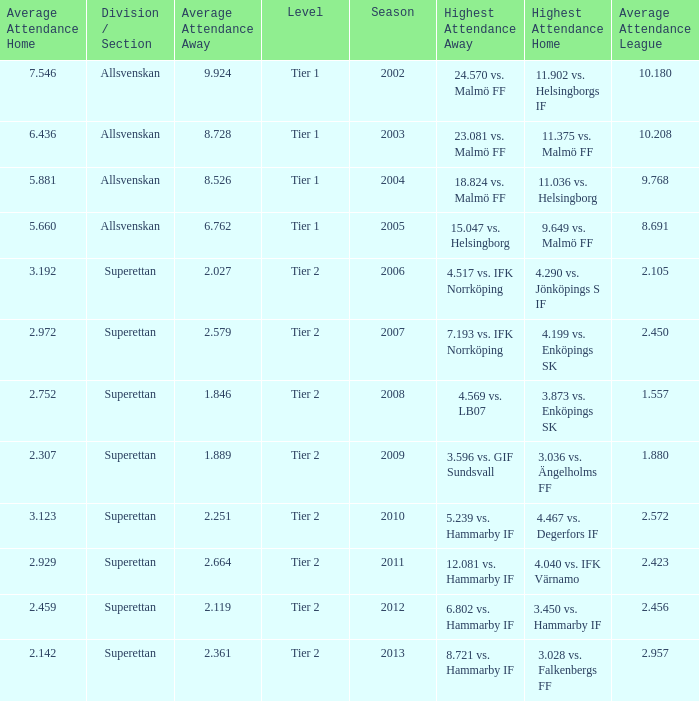How many season have an average attendance league of 2.456? 2012.0. 